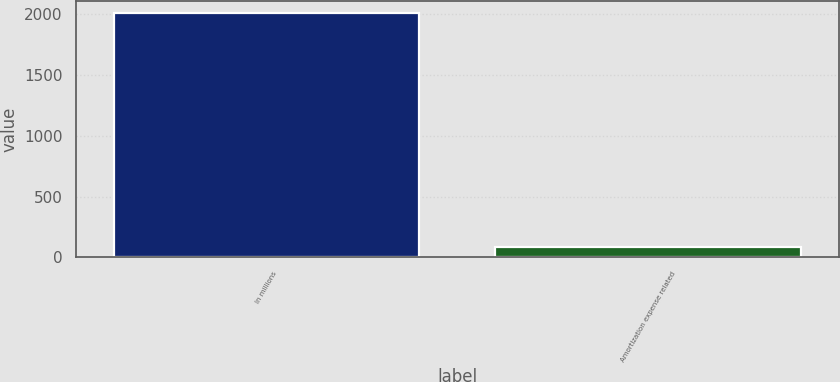Convert chart to OTSL. <chart><loc_0><loc_0><loc_500><loc_500><bar_chart><fcel>In millions<fcel>Amortization expense related<nl><fcel>2013<fcel>87<nl></chart> 